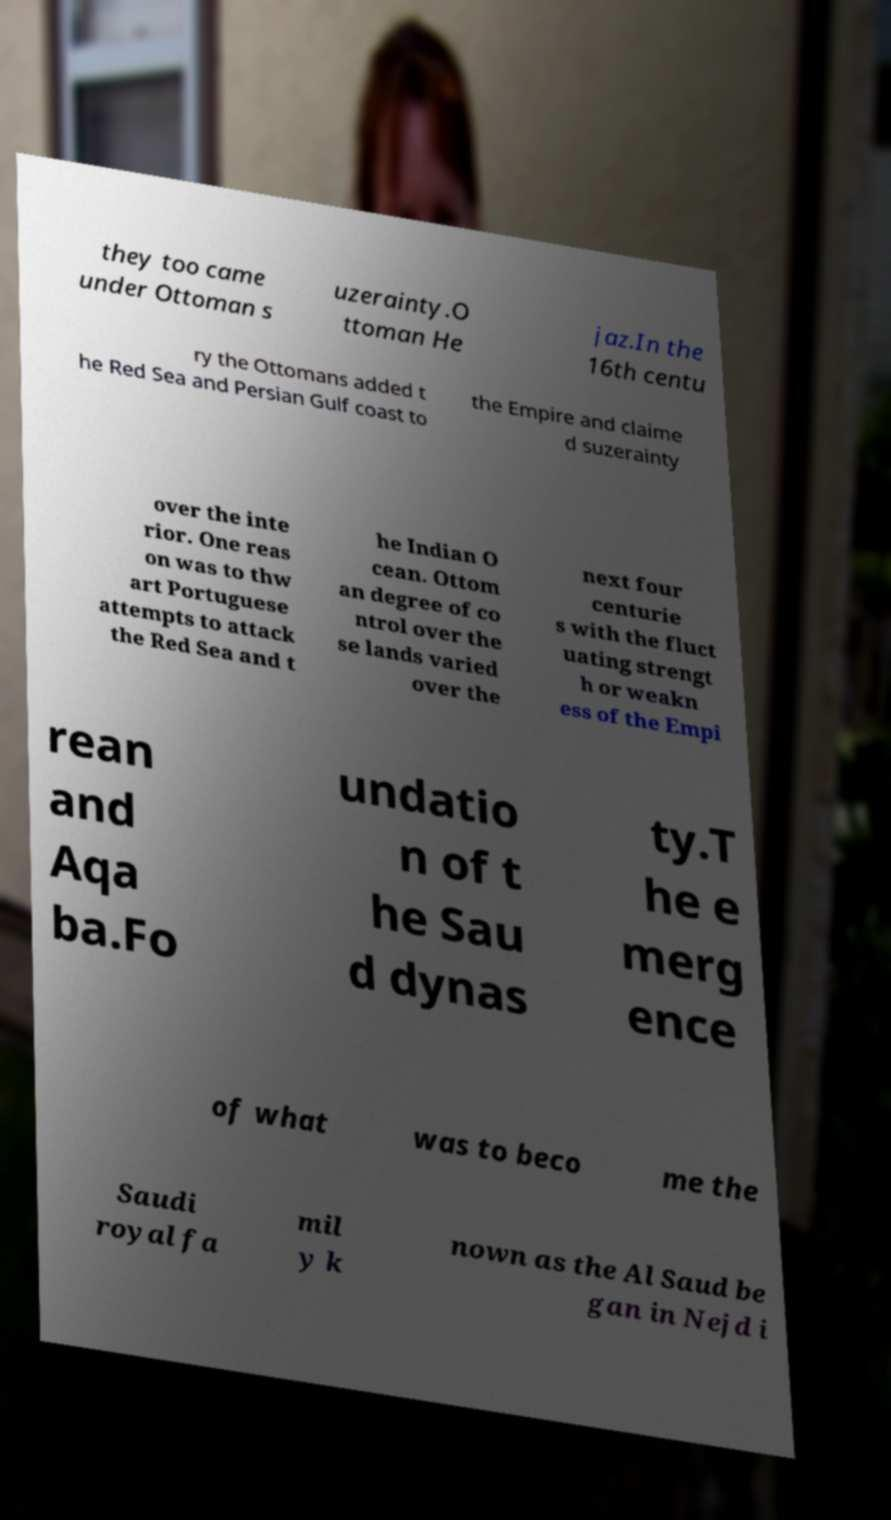Please identify and transcribe the text found in this image. they too came under Ottoman s uzerainty.O ttoman He jaz.In the 16th centu ry the Ottomans added t he Red Sea and Persian Gulf coast to the Empire and claime d suzerainty over the inte rior. One reas on was to thw art Portuguese attempts to attack the Red Sea and t he Indian O cean. Ottom an degree of co ntrol over the se lands varied over the next four centurie s with the fluct uating strengt h or weakn ess of the Empi rean and Aqa ba.Fo undatio n of t he Sau d dynas ty.T he e merg ence of what was to beco me the Saudi royal fa mil y k nown as the Al Saud be gan in Nejd i 